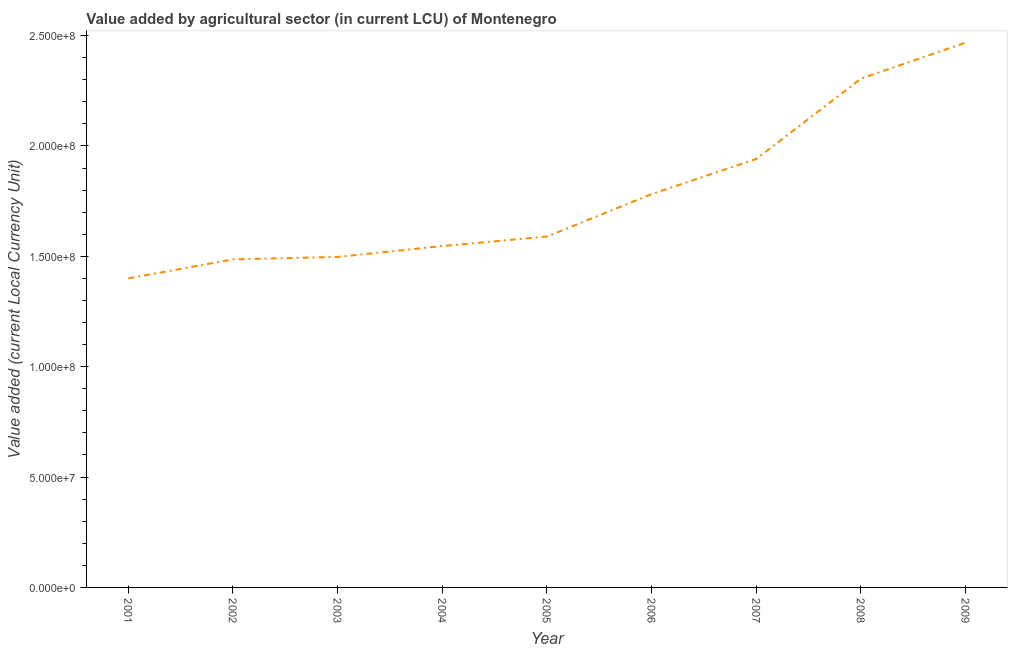What is the value added by agriculture sector in 2008?
Give a very brief answer. 2.30e+08. Across all years, what is the maximum value added by agriculture sector?
Keep it short and to the point. 2.47e+08. Across all years, what is the minimum value added by agriculture sector?
Your answer should be very brief. 1.40e+08. In which year was the value added by agriculture sector maximum?
Your answer should be very brief. 2009. What is the sum of the value added by agriculture sector?
Keep it short and to the point. 1.60e+09. What is the difference between the value added by agriculture sector in 2004 and 2008?
Give a very brief answer. -7.58e+07. What is the average value added by agriculture sector per year?
Offer a very short reply. 1.78e+08. What is the median value added by agriculture sector?
Ensure brevity in your answer.  1.59e+08. Do a majority of the years between 2009 and 2007 (inclusive) have value added by agriculture sector greater than 170000000 LCU?
Your answer should be very brief. No. What is the ratio of the value added by agriculture sector in 2002 to that in 2005?
Make the answer very short. 0.93. Is the value added by agriculture sector in 2004 less than that in 2009?
Offer a very short reply. Yes. What is the difference between the highest and the second highest value added by agriculture sector?
Provide a short and direct response. 1.63e+07. What is the difference between the highest and the lowest value added by agriculture sector?
Your response must be concise. 1.07e+08. How many lines are there?
Provide a short and direct response. 1. Are the values on the major ticks of Y-axis written in scientific E-notation?
Provide a short and direct response. Yes. What is the title of the graph?
Give a very brief answer. Value added by agricultural sector (in current LCU) of Montenegro. What is the label or title of the Y-axis?
Your response must be concise. Value added (current Local Currency Unit). What is the Value added (current Local Currency Unit) in 2001?
Your answer should be very brief. 1.40e+08. What is the Value added (current Local Currency Unit) of 2002?
Your answer should be compact. 1.49e+08. What is the Value added (current Local Currency Unit) of 2003?
Offer a terse response. 1.50e+08. What is the Value added (current Local Currency Unit) of 2004?
Ensure brevity in your answer.  1.55e+08. What is the Value added (current Local Currency Unit) of 2005?
Provide a short and direct response. 1.59e+08. What is the Value added (current Local Currency Unit) in 2006?
Make the answer very short. 1.78e+08. What is the Value added (current Local Currency Unit) in 2007?
Ensure brevity in your answer.  1.94e+08. What is the Value added (current Local Currency Unit) of 2008?
Your response must be concise. 2.30e+08. What is the Value added (current Local Currency Unit) in 2009?
Offer a terse response. 2.47e+08. What is the difference between the Value added (current Local Currency Unit) in 2001 and 2002?
Offer a terse response. -8.58e+06. What is the difference between the Value added (current Local Currency Unit) in 2001 and 2003?
Give a very brief answer. -9.71e+06. What is the difference between the Value added (current Local Currency Unit) in 2001 and 2004?
Your answer should be very brief. -1.46e+07. What is the difference between the Value added (current Local Currency Unit) in 2001 and 2005?
Give a very brief answer. -1.89e+07. What is the difference between the Value added (current Local Currency Unit) in 2001 and 2006?
Your response must be concise. -3.82e+07. What is the difference between the Value added (current Local Currency Unit) in 2001 and 2007?
Ensure brevity in your answer.  -5.41e+07. What is the difference between the Value added (current Local Currency Unit) in 2001 and 2008?
Your answer should be compact. -9.05e+07. What is the difference between the Value added (current Local Currency Unit) in 2001 and 2009?
Provide a succinct answer. -1.07e+08. What is the difference between the Value added (current Local Currency Unit) in 2002 and 2003?
Your answer should be compact. -1.13e+06. What is the difference between the Value added (current Local Currency Unit) in 2002 and 2004?
Offer a very short reply. -6.05e+06. What is the difference between the Value added (current Local Currency Unit) in 2002 and 2005?
Keep it short and to the point. -1.03e+07. What is the difference between the Value added (current Local Currency Unit) in 2002 and 2006?
Make the answer very short. -2.96e+07. What is the difference between the Value added (current Local Currency Unit) in 2002 and 2007?
Offer a very short reply. -4.55e+07. What is the difference between the Value added (current Local Currency Unit) in 2002 and 2008?
Provide a succinct answer. -8.19e+07. What is the difference between the Value added (current Local Currency Unit) in 2002 and 2009?
Provide a short and direct response. -9.82e+07. What is the difference between the Value added (current Local Currency Unit) in 2003 and 2004?
Make the answer very short. -4.92e+06. What is the difference between the Value added (current Local Currency Unit) in 2003 and 2005?
Your answer should be compact. -9.22e+06. What is the difference between the Value added (current Local Currency Unit) in 2003 and 2006?
Offer a terse response. -2.85e+07. What is the difference between the Value added (current Local Currency Unit) in 2003 and 2007?
Your answer should be very brief. -4.44e+07. What is the difference between the Value added (current Local Currency Unit) in 2003 and 2008?
Offer a very short reply. -8.08e+07. What is the difference between the Value added (current Local Currency Unit) in 2003 and 2009?
Make the answer very short. -9.71e+07. What is the difference between the Value added (current Local Currency Unit) in 2004 and 2005?
Provide a succinct answer. -4.30e+06. What is the difference between the Value added (current Local Currency Unit) in 2004 and 2006?
Offer a very short reply. -2.35e+07. What is the difference between the Value added (current Local Currency Unit) in 2004 and 2007?
Give a very brief answer. -3.95e+07. What is the difference between the Value added (current Local Currency Unit) in 2004 and 2008?
Offer a terse response. -7.58e+07. What is the difference between the Value added (current Local Currency Unit) in 2004 and 2009?
Keep it short and to the point. -9.22e+07. What is the difference between the Value added (current Local Currency Unit) in 2005 and 2006?
Your response must be concise. -1.92e+07. What is the difference between the Value added (current Local Currency Unit) in 2005 and 2007?
Your answer should be very brief. -3.52e+07. What is the difference between the Value added (current Local Currency Unit) in 2005 and 2008?
Provide a succinct answer. -7.15e+07. What is the difference between the Value added (current Local Currency Unit) in 2005 and 2009?
Your response must be concise. -8.79e+07. What is the difference between the Value added (current Local Currency Unit) in 2006 and 2007?
Provide a succinct answer. -1.59e+07. What is the difference between the Value added (current Local Currency Unit) in 2006 and 2008?
Your answer should be compact. -5.23e+07. What is the difference between the Value added (current Local Currency Unit) in 2006 and 2009?
Give a very brief answer. -6.86e+07. What is the difference between the Value added (current Local Currency Unit) in 2007 and 2008?
Provide a succinct answer. -3.64e+07. What is the difference between the Value added (current Local Currency Unit) in 2007 and 2009?
Provide a succinct answer. -5.27e+07. What is the difference between the Value added (current Local Currency Unit) in 2008 and 2009?
Make the answer very short. -1.63e+07. What is the ratio of the Value added (current Local Currency Unit) in 2001 to that in 2002?
Give a very brief answer. 0.94. What is the ratio of the Value added (current Local Currency Unit) in 2001 to that in 2003?
Your answer should be compact. 0.94. What is the ratio of the Value added (current Local Currency Unit) in 2001 to that in 2004?
Provide a short and direct response. 0.91. What is the ratio of the Value added (current Local Currency Unit) in 2001 to that in 2005?
Ensure brevity in your answer.  0.88. What is the ratio of the Value added (current Local Currency Unit) in 2001 to that in 2006?
Make the answer very short. 0.79. What is the ratio of the Value added (current Local Currency Unit) in 2001 to that in 2007?
Make the answer very short. 0.72. What is the ratio of the Value added (current Local Currency Unit) in 2001 to that in 2008?
Your response must be concise. 0.61. What is the ratio of the Value added (current Local Currency Unit) in 2001 to that in 2009?
Offer a terse response. 0.57. What is the ratio of the Value added (current Local Currency Unit) in 2002 to that in 2004?
Your response must be concise. 0.96. What is the ratio of the Value added (current Local Currency Unit) in 2002 to that in 2005?
Offer a terse response. 0.94. What is the ratio of the Value added (current Local Currency Unit) in 2002 to that in 2006?
Give a very brief answer. 0.83. What is the ratio of the Value added (current Local Currency Unit) in 2002 to that in 2007?
Provide a short and direct response. 0.77. What is the ratio of the Value added (current Local Currency Unit) in 2002 to that in 2008?
Offer a very short reply. 0.65. What is the ratio of the Value added (current Local Currency Unit) in 2002 to that in 2009?
Provide a succinct answer. 0.6. What is the ratio of the Value added (current Local Currency Unit) in 2003 to that in 2005?
Make the answer very short. 0.94. What is the ratio of the Value added (current Local Currency Unit) in 2003 to that in 2006?
Make the answer very short. 0.84. What is the ratio of the Value added (current Local Currency Unit) in 2003 to that in 2007?
Your answer should be compact. 0.77. What is the ratio of the Value added (current Local Currency Unit) in 2003 to that in 2008?
Provide a succinct answer. 0.65. What is the ratio of the Value added (current Local Currency Unit) in 2003 to that in 2009?
Provide a short and direct response. 0.61. What is the ratio of the Value added (current Local Currency Unit) in 2004 to that in 2006?
Make the answer very short. 0.87. What is the ratio of the Value added (current Local Currency Unit) in 2004 to that in 2007?
Your answer should be compact. 0.8. What is the ratio of the Value added (current Local Currency Unit) in 2004 to that in 2008?
Your answer should be compact. 0.67. What is the ratio of the Value added (current Local Currency Unit) in 2004 to that in 2009?
Ensure brevity in your answer.  0.63. What is the ratio of the Value added (current Local Currency Unit) in 2005 to that in 2006?
Offer a terse response. 0.89. What is the ratio of the Value added (current Local Currency Unit) in 2005 to that in 2007?
Provide a short and direct response. 0.82. What is the ratio of the Value added (current Local Currency Unit) in 2005 to that in 2008?
Your answer should be compact. 0.69. What is the ratio of the Value added (current Local Currency Unit) in 2005 to that in 2009?
Provide a succinct answer. 0.64. What is the ratio of the Value added (current Local Currency Unit) in 2006 to that in 2007?
Your answer should be compact. 0.92. What is the ratio of the Value added (current Local Currency Unit) in 2006 to that in 2008?
Offer a terse response. 0.77. What is the ratio of the Value added (current Local Currency Unit) in 2006 to that in 2009?
Offer a terse response. 0.72. What is the ratio of the Value added (current Local Currency Unit) in 2007 to that in 2008?
Offer a terse response. 0.84. What is the ratio of the Value added (current Local Currency Unit) in 2007 to that in 2009?
Offer a very short reply. 0.79. What is the ratio of the Value added (current Local Currency Unit) in 2008 to that in 2009?
Make the answer very short. 0.93. 